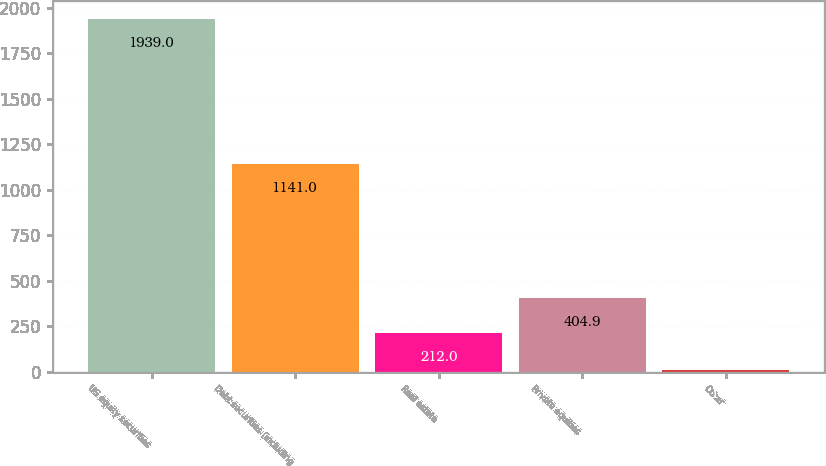<chart> <loc_0><loc_0><loc_500><loc_500><bar_chart><fcel>US equity securities<fcel>Debt securities (including<fcel>Real estate<fcel>Private equities<fcel>Other<nl><fcel>1939<fcel>1141<fcel>212<fcel>404.9<fcel>10<nl></chart> 